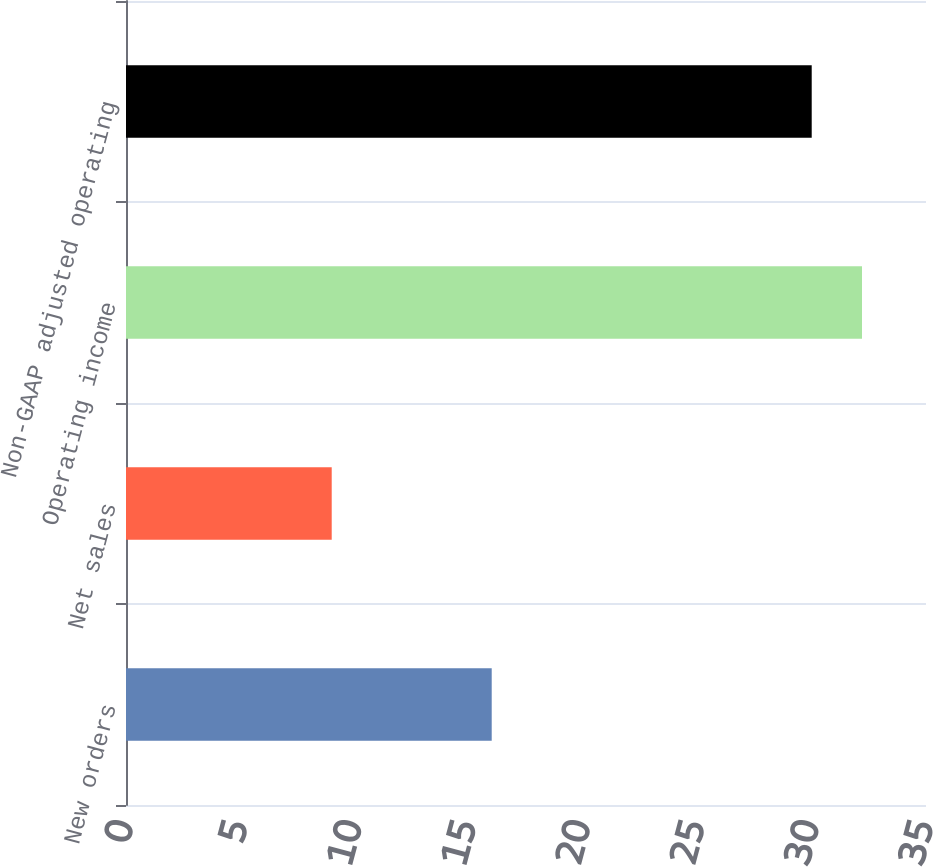<chart> <loc_0><loc_0><loc_500><loc_500><bar_chart><fcel>New orders<fcel>Net sales<fcel>Operating income<fcel>Non-GAAP adjusted operating<nl><fcel>16<fcel>9<fcel>32.2<fcel>30<nl></chart> 